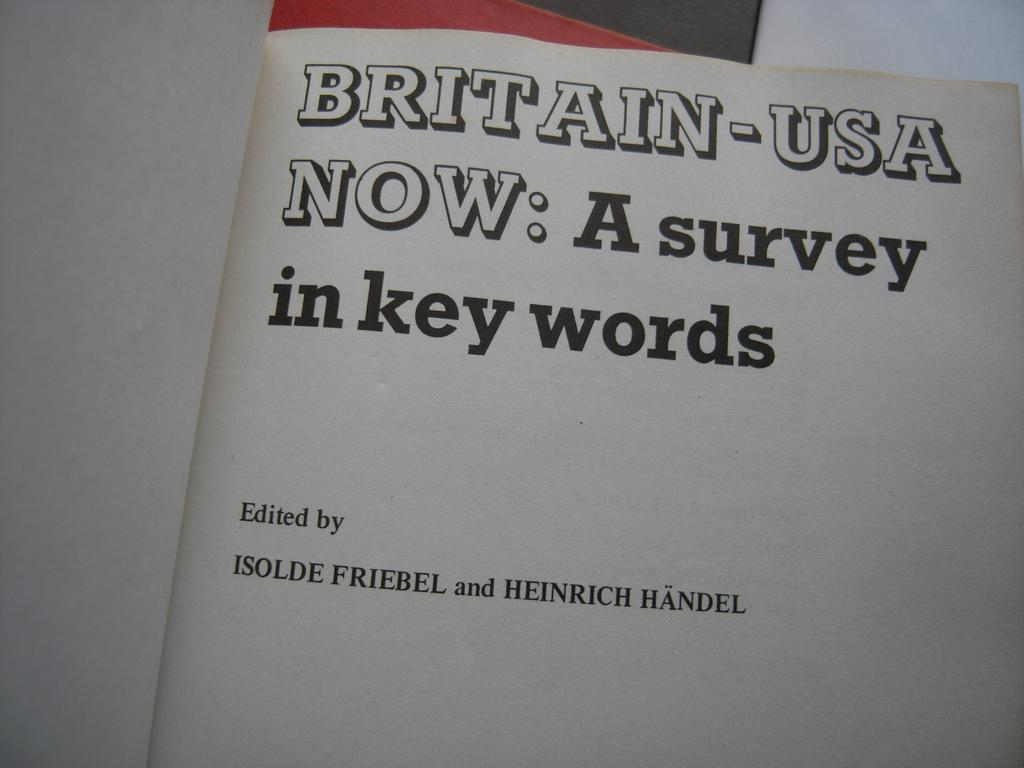<image>
Render a clear and concise summary of the photo. A book which is open to a page that says, "Britain-USA Now: A survey in key words". 